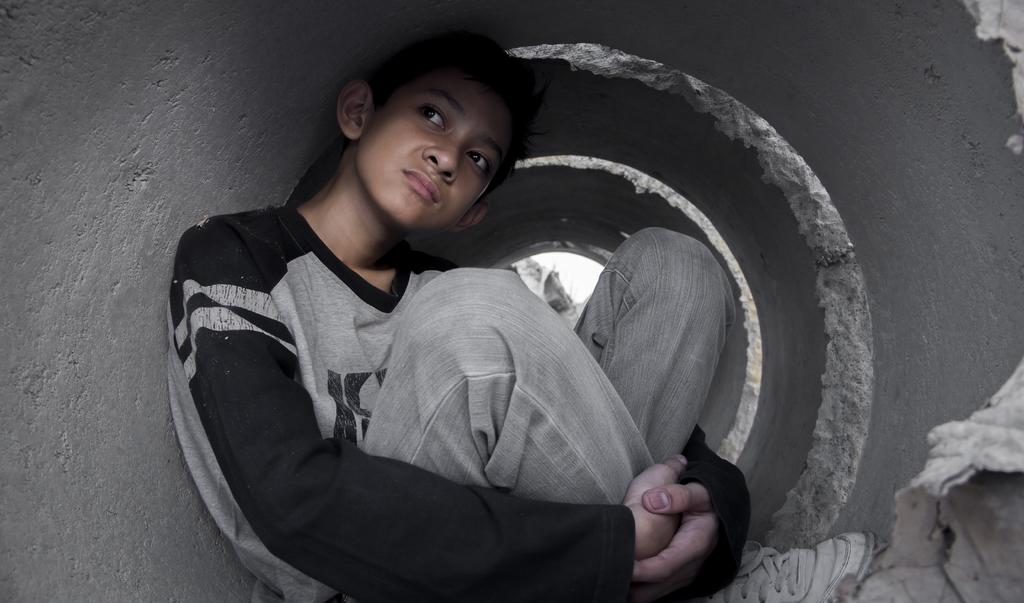What is the main subject in the foreground of the image? There is a boy in the foreground of the image. What is the boy doing in the image? The boy is sitting inside a pipe-like object. What type of soup is the boy eating in the image? There is no soup present in the image; the boy is sitting inside a pipe-like object. 